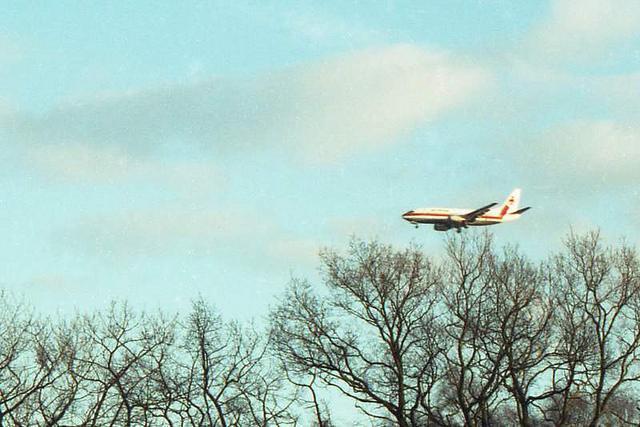How many blue cars are there?
Give a very brief answer. 0. 